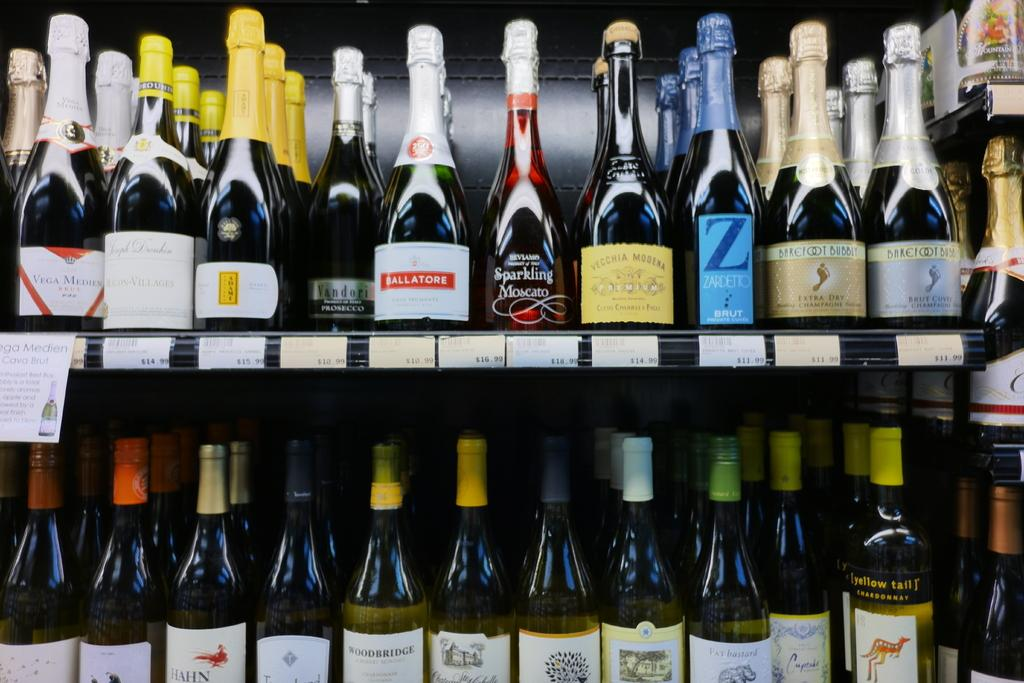<image>
Render a clear and concise summary of the photo. Two rows of bottles of wine and champagne including Ballatore brand. 